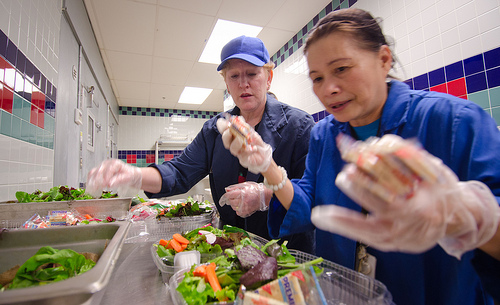<image>
Is the lunch under the cap? No. The lunch is not positioned under the cap. The vertical relationship between these objects is different. Is there a glove under the hat? No. The glove is not positioned under the hat. The vertical relationship between these objects is different. 